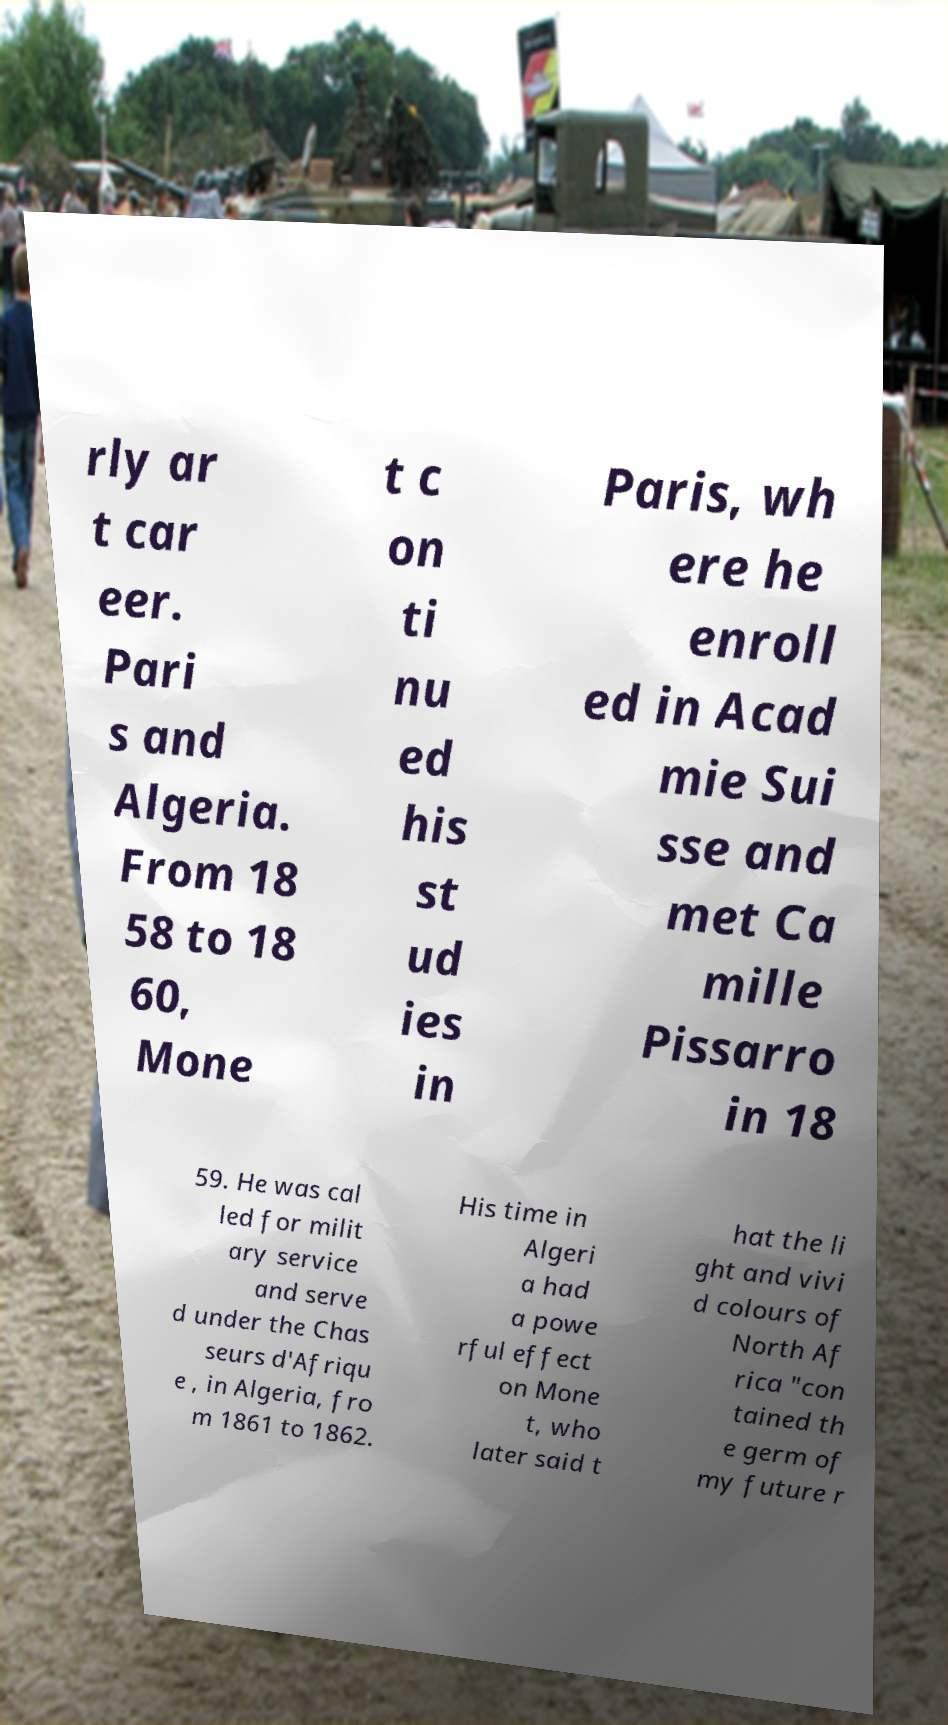Can you read and provide the text displayed in the image?This photo seems to have some interesting text. Can you extract and type it out for me? rly ar t car eer. Pari s and Algeria. From 18 58 to 18 60, Mone t c on ti nu ed his st ud ies in Paris, wh ere he enroll ed in Acad mie Sui sse and met Ca mille Pissarro in 18 59. He was cal led for milit ary service and serve d under the Chas seurs d'Afriqu e , in Algeria, fro m 1861 to 1862. His time in Algeri a had a powe rful effect on Mone t, who later said t hat the li ght and vivi d colours of North Af rica "con tained th e germ of my future r 